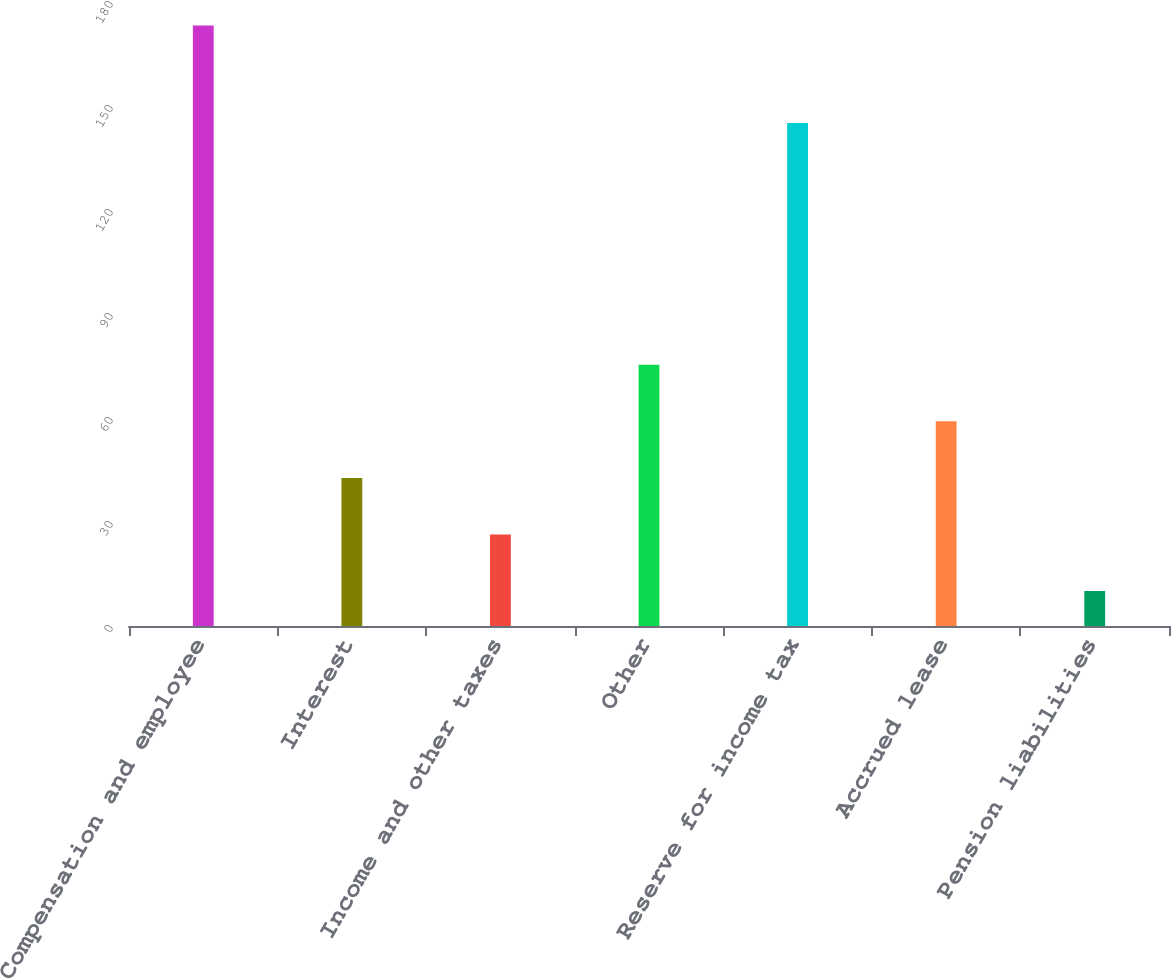Convert chart to OTSL. <chart><loc_0><loc_0><loc_500><loc_500><bar_chart><fcel>Compensation and employee<fcel>Interest<fcel>Income and other taxes<fcel>Other<fcel>Reserve for income tax<fcel>Accrued lease<fcel>Pension liabilities<nl><fcel>173.2<fcel>42.72<fcel>26.41<fcel>75.34<fcel>145.1<fcel>59.03<fcel>10.1<nl></chart> 